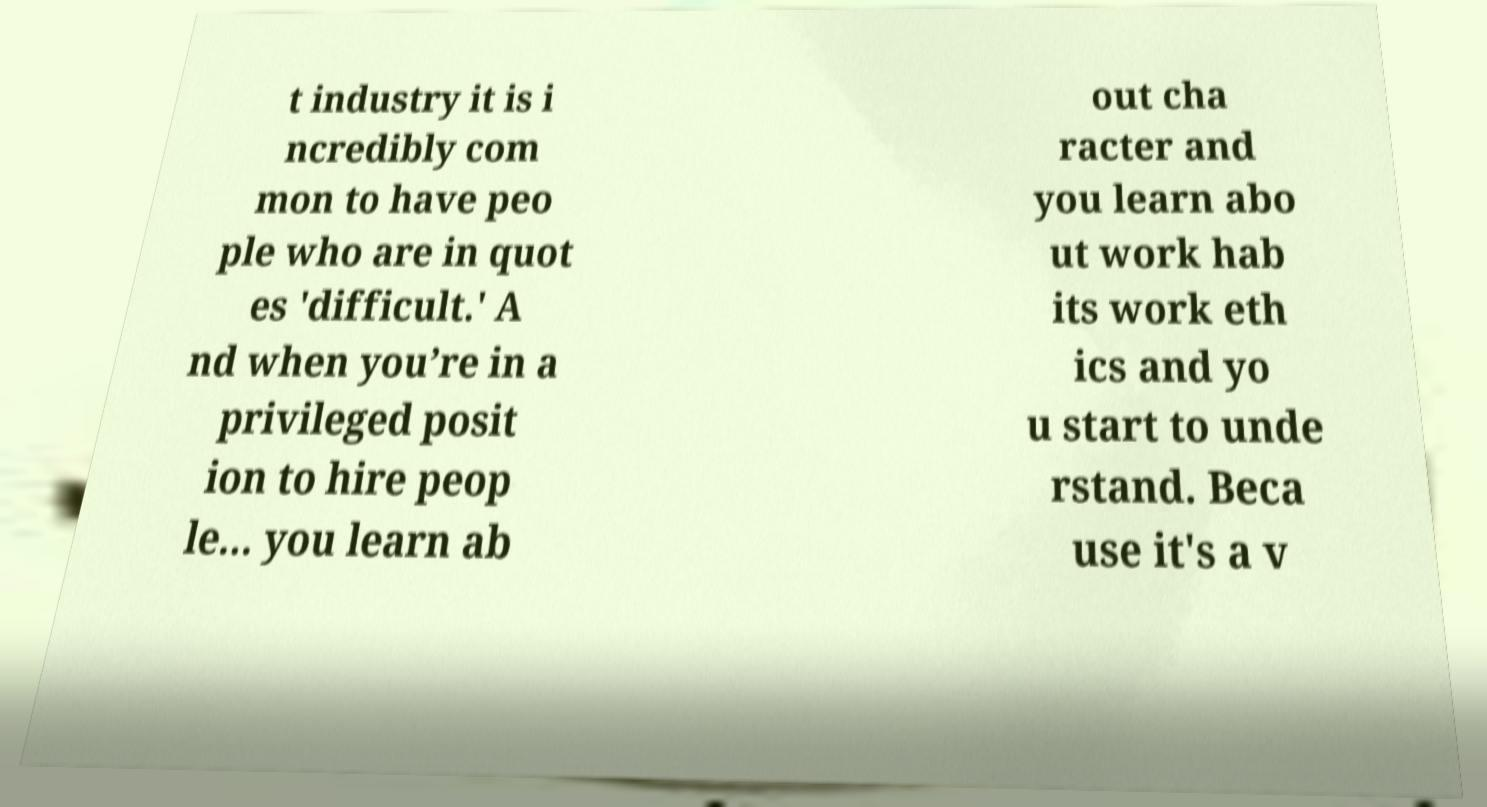Please read and relay the text visible in this image. What does it say? t industry it is i ncredibly com mon to have peo ple who are in quot es 'difficult.' A nd when you’re in a privileged posit ion to hire peop le... you learn ab out cha racter and you learn abo ut work hab its work eth ics and yo u start to unde rstand. Beca use it's a v 